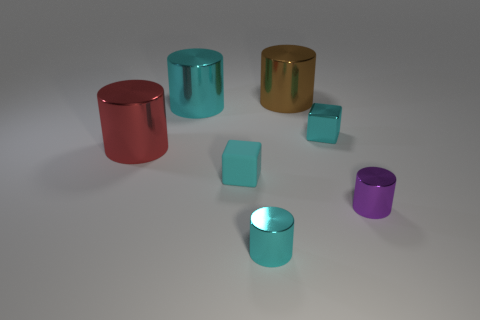Subtract all blue cubes. How many cyan cylinders are left? 2 Subtract all big metallic cylinders. How many cylinders are left? 2 Subtract all cyan cylinders. How many cylinders are left? 3 Add 2 cyan shiny cubes. How many objects exist? 9 Subtract all cylinders. How many objects are left? 2 Subtract all blue cylinders. Subtract all blue blocks. How many cylinders are left? 5 Add 7 big blue cubes. How many big blue cubes exist? 7 Subtract 0 green blocks. How many objects are left? 7 Subtract all large blue cylinders. Subtract all purple shiny cylinders. How many objects are left? 6 Add 4 tiny purple shiny cylinders. How many tiny purple shiny cylinders are left? 5 